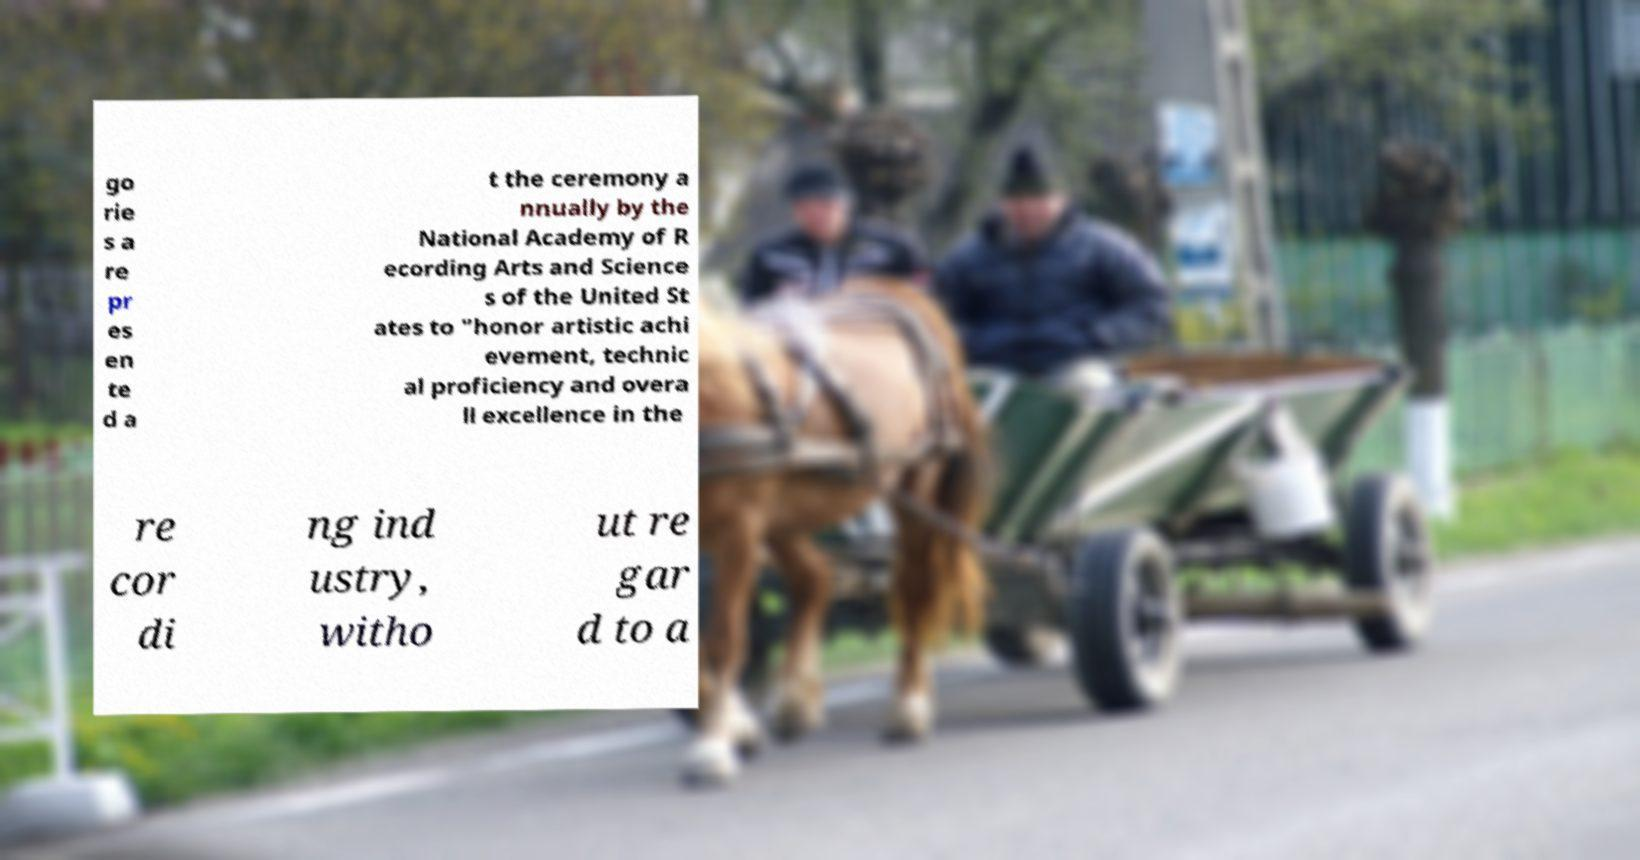For documentation purposes, I need the text within this image transcribed. Could you provide that? go rie s a re pr es en te d a t the ceremony a nnually by the National Academy of R ecording Arts and Science s of the United St ates to "honor artistic achi evement, technic al proficiency and overa ll excellence in the re cor di ng ind ustry, witho ut re gar d to a 